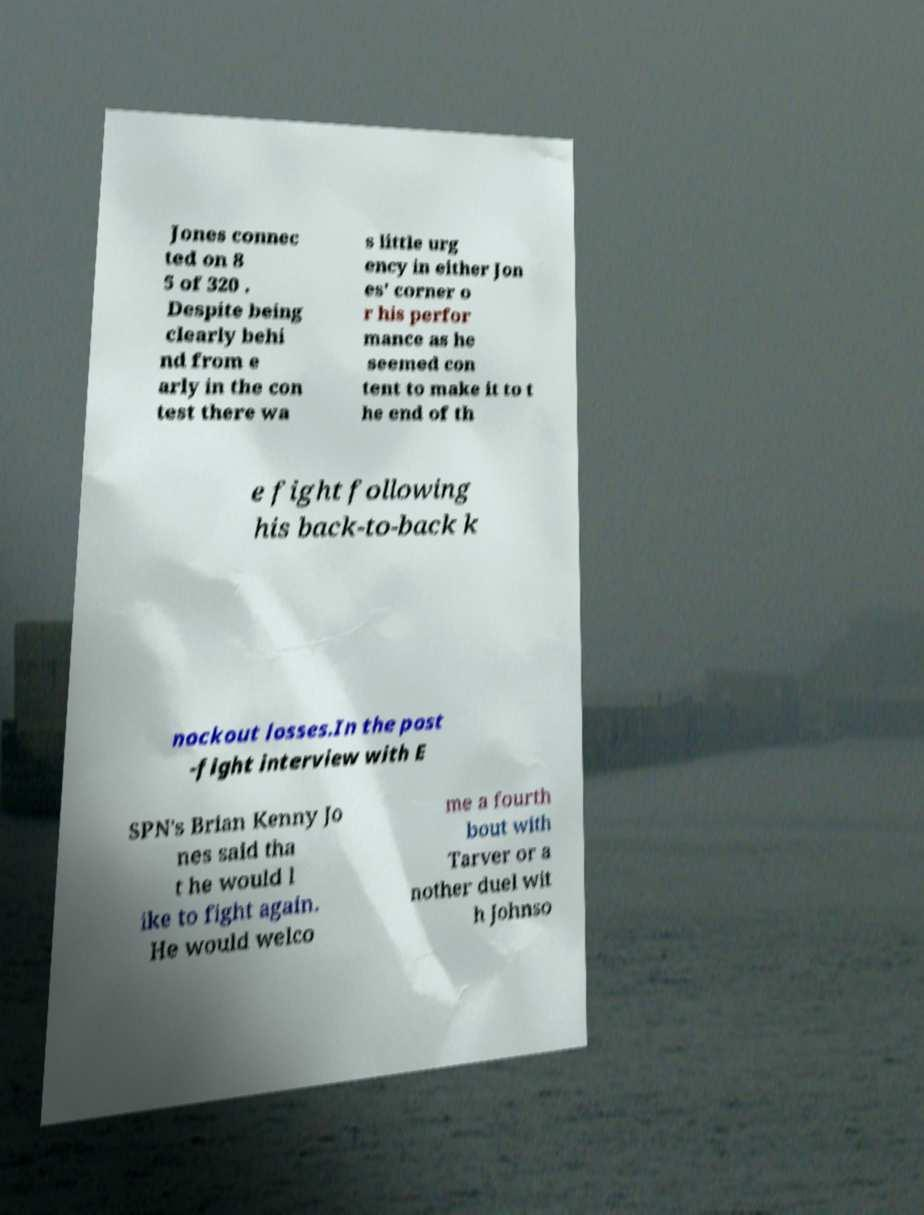What messages or text are displayed in this image? I need them in a readable, typed format. Jones connec ted on 8 5 of 320 . Despite being clearly behi nd from e arly in the con test there wa s little urg ency in either Jon es' corner o r his perfor mance as he seemed con tent to make it to t he end of th e fight following his back-to-back k nockout losses.In the post -fight interview with E SPN's Brian Kenny Jo nes said tha t he would l ike to fight again. He would welco me a fourth bout with Tarver or a nother duel wit h Johnso 